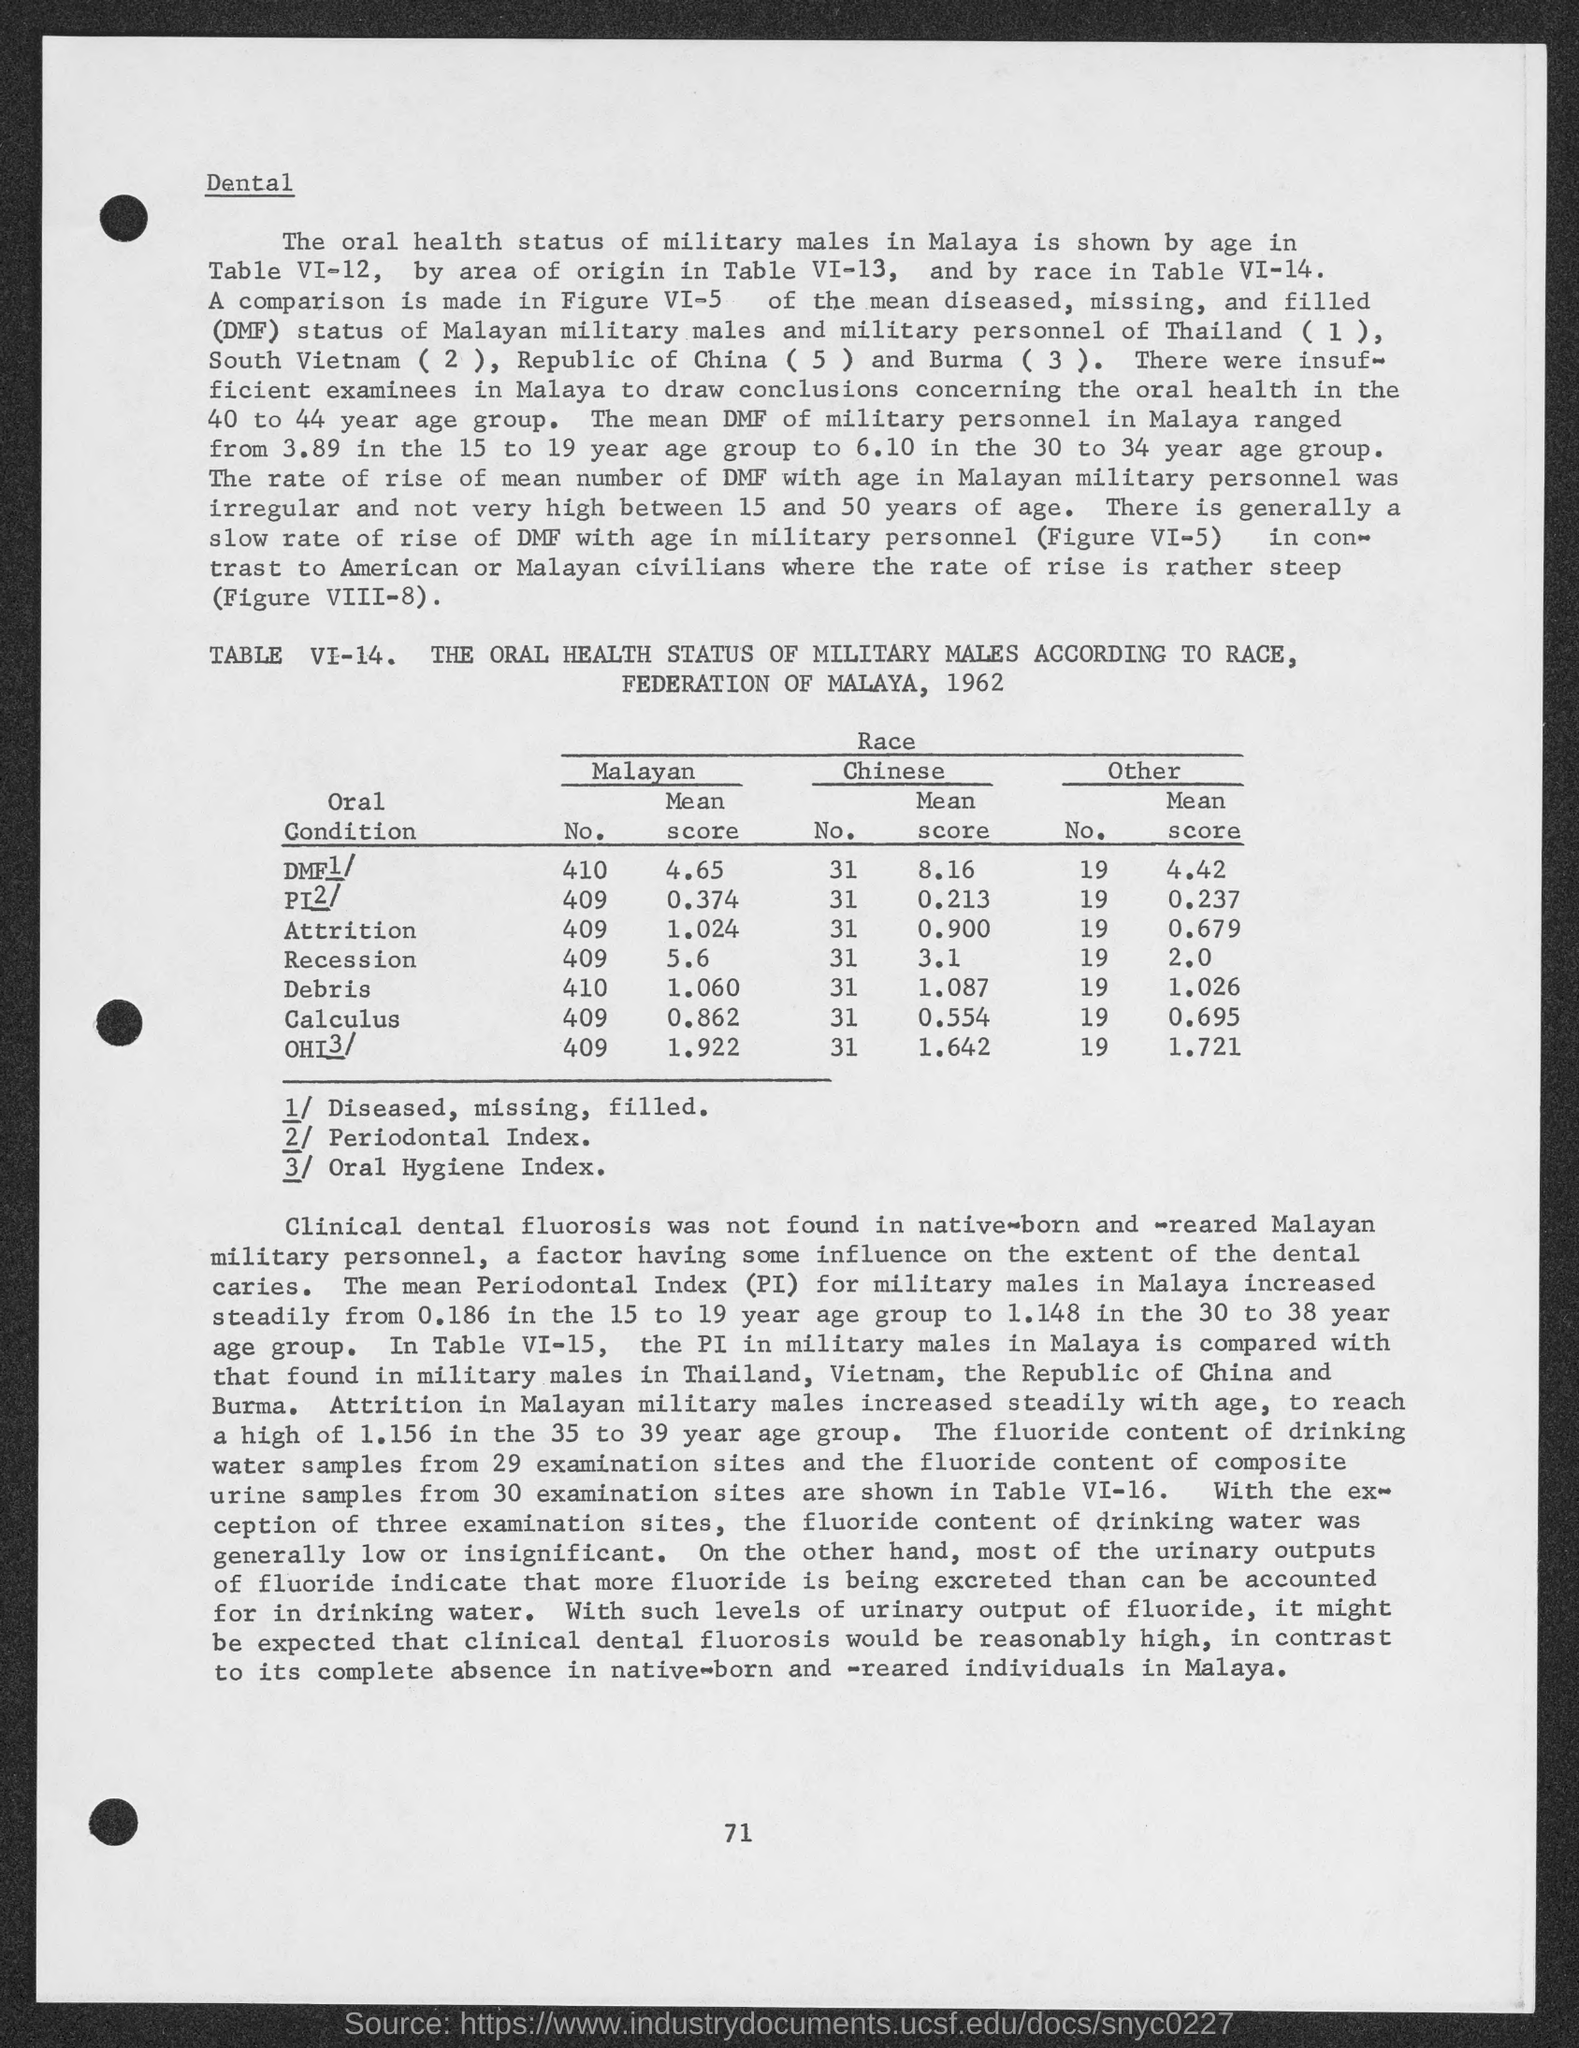Give some essential details in this illustration. The mean score for Debris in Malaysia is The Malayan mean score for attrition is 1.024. The Malayan mean score for Calculus is 0.862... The Chinese mean score for Calculus is 0.554... The Chinese interpretation of the recession score is 3.1. 